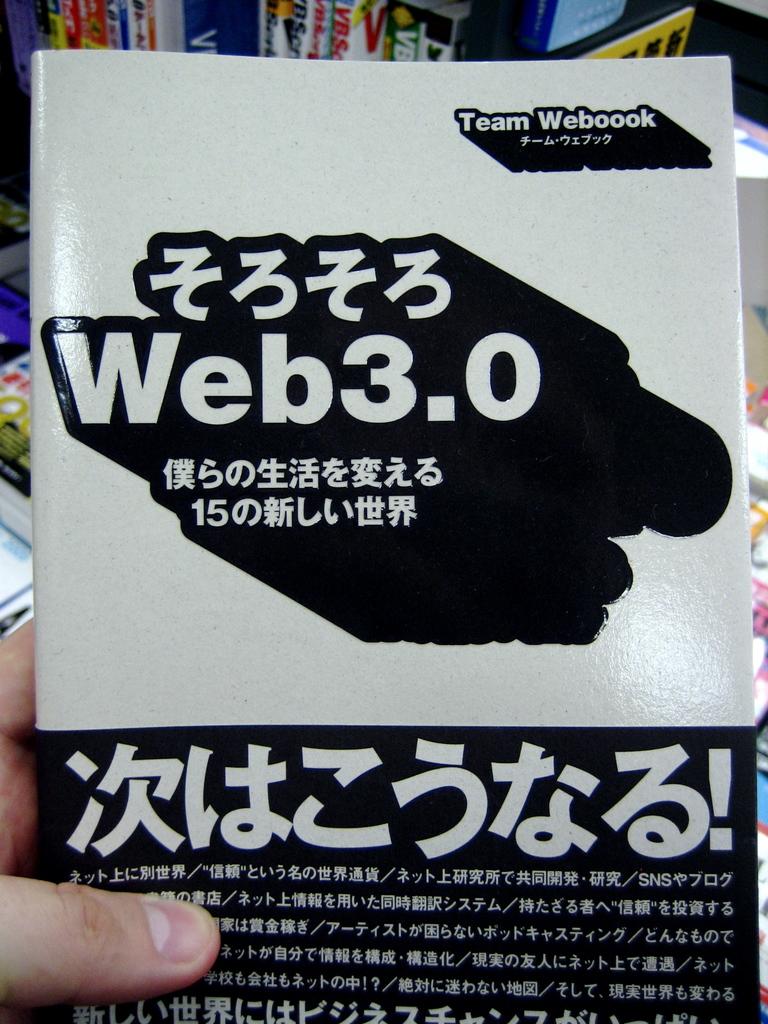What web version is pictured?
Ensure brevity in your answer.  3.0. 